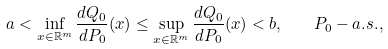<formula> <loc_0><loc_0><loc_500><loc_500>a < \inf _ { x \in \mathbb { R } ^ { m } } \frac { d Q _ { 0 } } { d P _ { 0 } } ( x ) \leq \sup _ { x \in \mathbb { R } ^ { m } } \frac { d Q _ { 0 } } { d P _ { 0 } } ( x ) < b , \quad P _ { 0 } - a . s . ,</formula> 